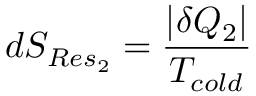Convert formula to latex. <formula><loc_0><loc_0><loc_500><loc_500>d S _ { R e s _ { 2 } } = { \frac { | \delta Q _ { 2 } | } { T _ { c o l d } } }</formula> 